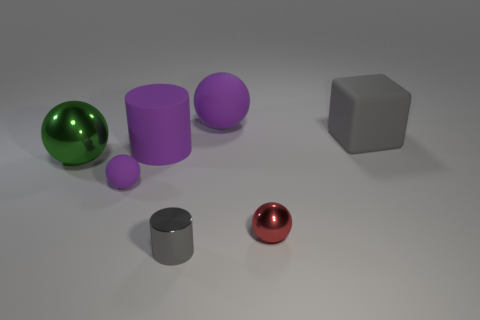Subtract all purple balls. How many were subtracted if there are1purple balls left? 1 Add 3 metal spheres. How many objects exist? 10 Subtract all gray cylinders. How many cylinders are left? 1 Subtract all red metallic balls. How many balls are left? 3 Subtract all cylinders. How many objects are left? 5 Subtract 1 cylinders. How many cylinders are left? 1 Subtract all cyan balls. How many purple cylinders are left? 1 Subtract all blue cylinders. Subtract all purple balls. How many cylinders are left? 2 Subtract all big cyan cylinders. Subtract all metal things. How many objects are left? 4 Add 6 purple rubber cylinders. How many purple rubber cylinders are left? 7 